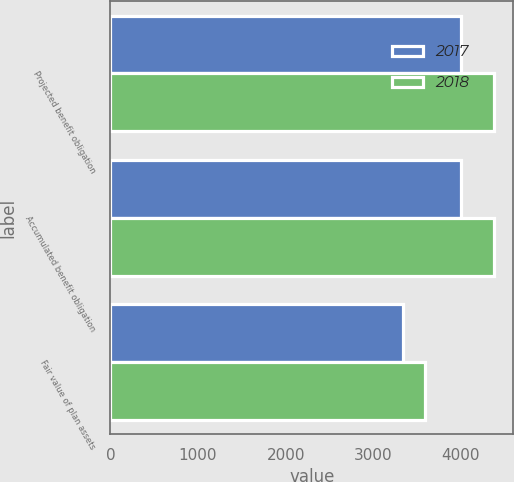Convert chart. <chart><loc_0><loc_0><loc_500><loc_500><stacked_bar_chart><ecel><fcel>Projected benefit obligation<fcel>Accumulated benefit obligation<fcel>Fair value of plan assets<nl><fcel>2017<fcel>4000<fcel>4000<fcel>3344<nl><fcel>2018<fcel>4376<fcel>4376<fcel>3592<nl></chart> 